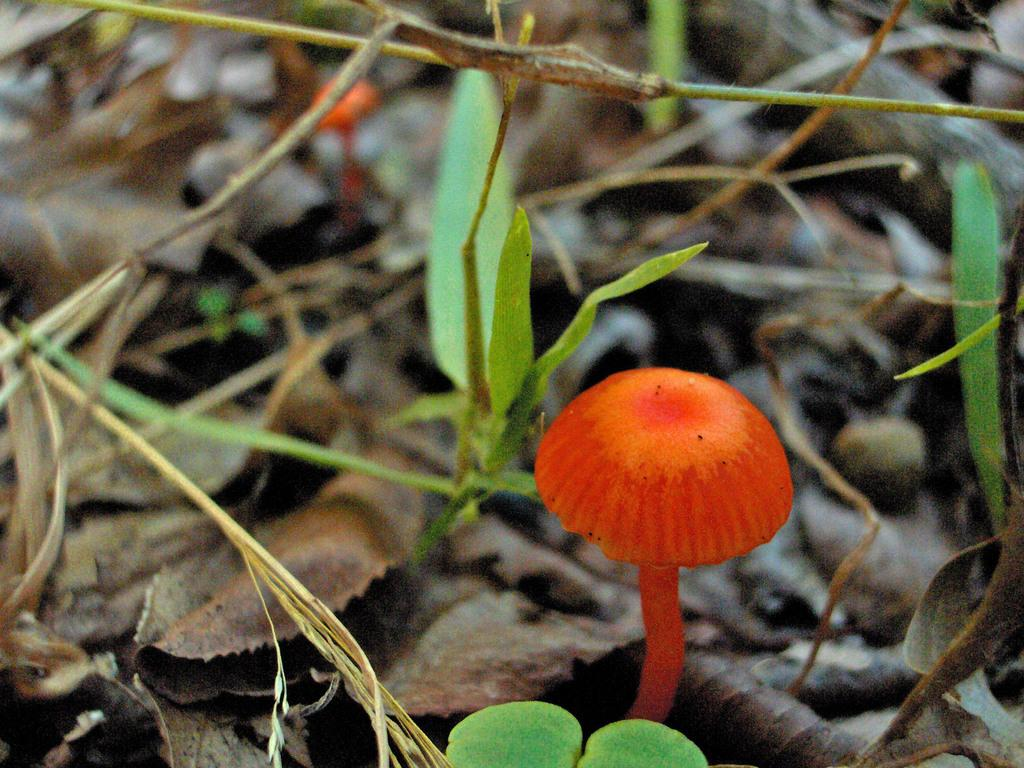What color are the mushrooms in the image? The mushrooms in the image are orange. What other types of vegetation can be seen in the image? There are plants in the image. What is the condition of the leaves in the image? The leaves in the image are dried. How many dinosaurs can be seen in the image? There are no dinosaurs present in the image. What type of metal is the back of the mushroom made of? The mushrooms in the image are not made of metal, and there is no mention of a back. 